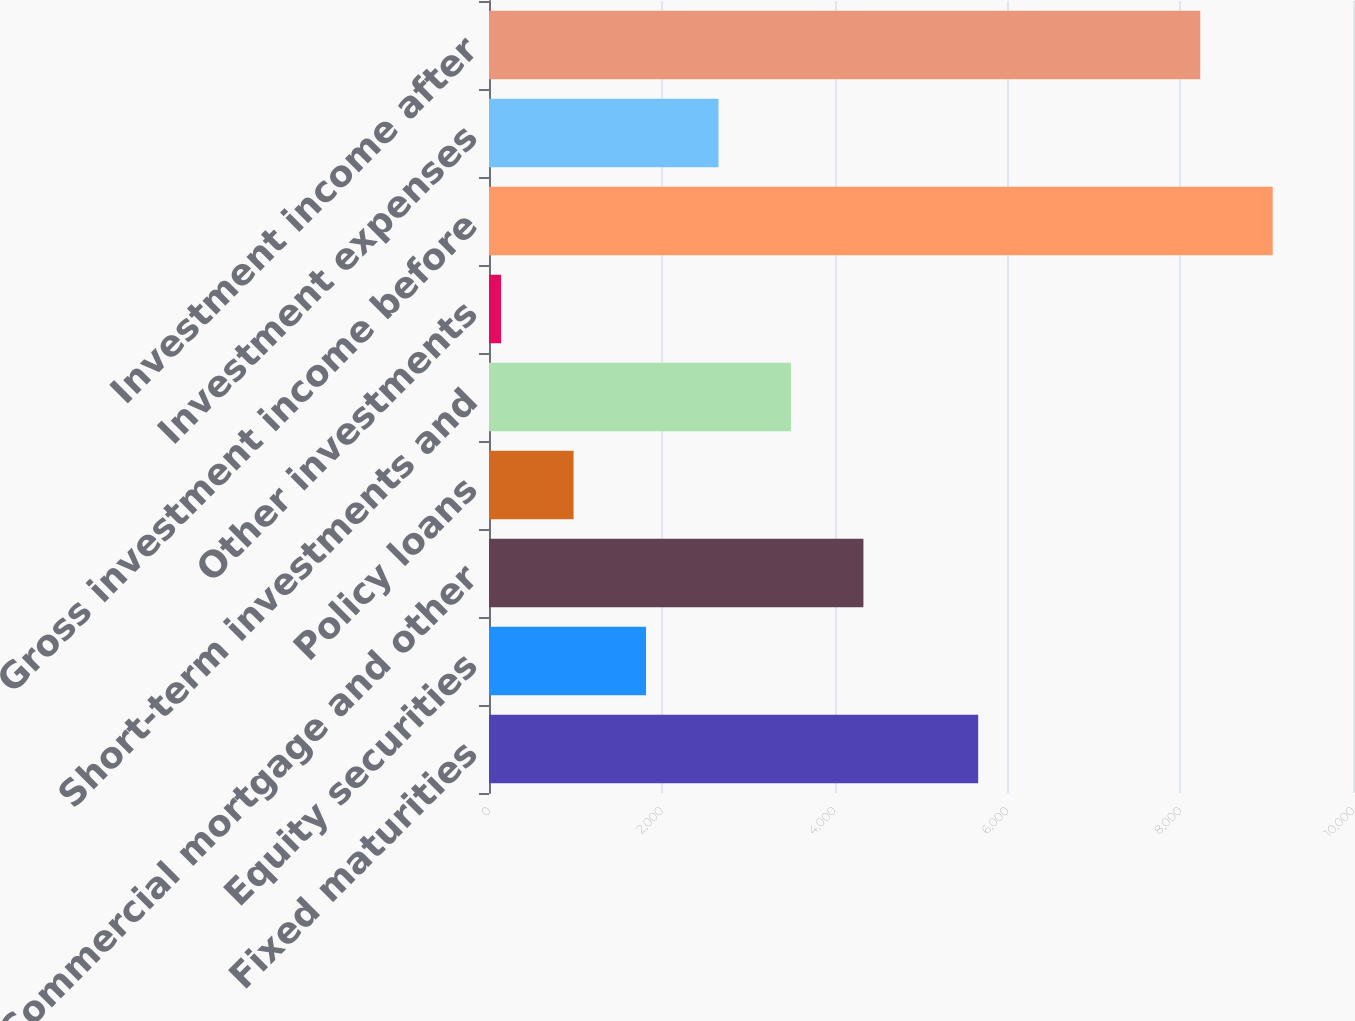<chart> <loc_0><loc_0><loc_500><loc_500><bar_chart><fcel>Fixed maturities<fcel>Equity securities<fcel>Commercial mortgage and other<fcel>Policy loans<fcel>Short-term investments and<fcel>Other investments<fcel>Gross investment income before<fcel>Investment expenses<fcel>Investment income after<nl><fcel>5662<fcel>1817.4<fcel>4333.5<fcel>978.7<fcel>3494.8<fcel>140<fcel>9070.7<fcel>2656.1<fcel>8232<nl></chart> 